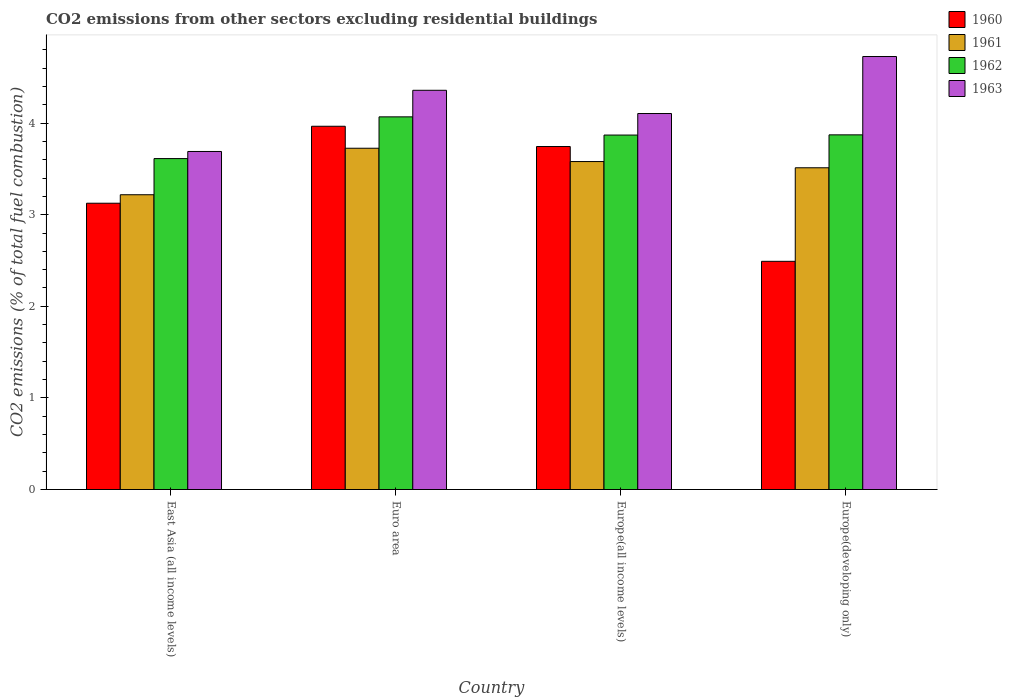How many different coloured bars are there?
Your answer should be compact. 4. How many groups of bars are there?
Offer a terse response. 4. How many bars are there on the 2nd tick from the left?
Provide a succinct answer. 4. What is the label of the 4th group of bars from the left?
Your answer should be very brief. Europe(developing only). What is the total CO2 emitted in 1963 in Europe(all income levels)?
Your answer should be very brief. 4.1. Across all countries, what is the maximum total CO2 emitted in 1962?
Offer a terse response. 4.07. Across all countries, what is the minimum total CO2 emitted in 1962?
Provide a short and direct response. 3.61. In which country was the total CO2 emitted in 1960 minimum?
Provide a short and direct response. Europe(developing only). What is the total total CO2 emitted in 1960 in the graph?
Offer a very short reply. 13.33. What is the difference between the total CO2 emitted in 1961 in East Asia (all income levels) and that in Europe(all income levels)?
Provide a short and direct response. -0.36. What is the difference between the total CO2 emitted in 1962 in Euro area and the total CO2 emitted in 1961 in East Asia (all income levels)?
Your answer should be very brief. 0.85. What is the average total CO2 emitted in 1961 per country?
Provide a succinct answer. 3.51. What is the difference between the total CO2 emitted of/in 1960 and total CO2 emitted of/in 1961 in Europe(all income levels)?
Make the answer very short. 0.16. What is the ratio of the total CO2 emitted in 1962 in East Asia (all income levels) to that in Europe(developing only)?
Offer a terse response. 0.93. What is the difference between the highest and the second highest total CO2 emitted in 1961?
Make the answer very short. 0.07. What is the difference between the highest and the lowest total CO2 emitted in 1960?
Keep it short and to the point. 1.47. In how many countries, is the total CO2 emitted in 1960 greater than the average total CO2 emitted in 1960 taken over all countries?
Your answer should be very brief. 2. What does the 1st bar from the left in Euro area represents?
Make the answer very short. 1960. Is it the case that in every country, the sum of the total CO2 emitted in 1960 and total CO2 emitted in 1963 is greater than the total CO2 emitted in 1962?
Provide a succinct answer. Yes. How many bars are there?
Make the answer very short. 16. Are all the bars in the graph horizontal?
Offer a very short reply. No. What is the difference between two consecutive major ticks on the Y-axis?
Ensure brevity in your answer.  1. Does the graph contain any zero values?
Ensure brevity in your answer.  No. How many legend labels are there?
Make the answer very short. 4. How are the legend labels stacked?
Your answer should be very brief. Vertical. What is the title of the graph?
Offer a very short reply. CO2 emissions from other sectors excluding residential buildings. Does "1979" appear as one of the legend labels in the graph?
Ensure brevity in your answer.  No. What is the label or title of the X-axis?
Your answer should be compact. Country. What is the label or title of the Y-axis?
Your answer should be very brief. CO2 emissions (% of total fuel combustion). What is the CO2 emissions (% of total fuel combustion) in 1960 in East Asia (all income levels)?
Provide a short and direct response. 3.13. What is the CO2 emissions (% of total fuel combustion) in 1961 in East Asia (all income levels)?
Your response must be concise. 3.22. What is the CO2 emissions (% of total fuel combustion) of 1962 in East Asia (all income levels)?
Your answer should be compact. 3.61. What is the CO2 emissions (% of total fuel combustion) of 1963 in East Asia (all income levels)?
Ensure brevity in your answer.  3.69. What is the CO2 emissions (% of total fuel combustion) in 1960 in Euro area?
Ensure brevity in your answer.  3.97. What is the CO2 emissions (% of total fuel combustion) in 1961 in Euro area?
Provide a succinct answer. 3.73. What is the CO2 emissions (% of total fuel combustion) of 1962 in Euro area?
Your response must be concise. 4.07. What is the CO2 emissions (% of total fuel combustion) of 1963 in Euro area?
Your answer should be compact. 4.36. What is the CO2 emissions (% of total fuel combustion) of 1960 in Europe(all income levels)?
Your response must be concise. 3.74. What is the CO2 emissions (% of total fuel combustion) in 1961 in Europe(all income levels)?
Your answer should be very brief. 3.58. What is the CO2 emissions (% of total fuel combustion) in 1962 in Europe(all income levels)?
Your answer should be very brief. 3.87. What is the CO2 emissions (% of total fuel combustion) in 1963 in Europe(all income levels)?
Offer a terse response. 4.1. What is the CO2 emissions (% of total fuel combustion) in 1960 in Europe(developing only)?
Offer a terse response. 2.49. What is the CO2 emissions (% of total fuel combustion) of 1961 in Europe(developing only)?
Provide a succinct answer. 3.51. What is the CO2 emissions (% of total fuel combustion) of 1962 in Europe(developing only)?
Make the answer very short. 3.87. What is the CO2 emissions (% of total fuel combustion) in 1963 in Europe(developing only)?
Your answer should be compact. 4.73. Across all countries, what is the maximum CO2 emissions (% of total fuel combustion) in 1960?
Keep it short and to the point. 3.97. Across all countries, what is the maximum CO2 emissions (% of total fuel combustion) of 1961?
Ensure brevity in your answer.  3.73. Across all countries, what is the maximum CO2 emissions (% of total fuel combustion) in 1962?
Keep it short and to the point. 4.07. Across all countries, what is the maximum CO2 emissions (% of total fuel combustion) in 1963?
Your answer should be compact. 4.73. Across all countries, what is the minimum CO2 emissions (% of total fuel combustion) in 1960?
Make the answer very short. 2.49. Across all countries, what is the minimum CO2 emissions (% of total fuel combustion) in 1961?
Offer a very short reply. 3.22. Across all countries, what is the minimum CO2 emissions (% of total fuel combustion) in 1962?
Your response must be concise. 3.61. Across all countries, what is the minimum CO2 emissions (% of total fuel combustion) of 1963?
Provide a succinct answer. 3.69. What is the total CO2 emissions (% of total fuel combustion) of 1960 in the graph?
Your answer should be very brief. 13.32. What is the total CO2 emissions (% of total fuel combustion) in 1961 in the graph?
Offer a very short reply. 14.03. What is the total CO2 emissions (% of total fuel combustion) in 1962 in the graph?
Offer a very short reply. 15.42. What is the total CO2 emissions (% of total fuel combustion) in 1963 in the graph?
Offer a very short reply. 16.88. What is the difference between the CO2 emissions (% of total fuel combustion) in 1960 in East Asia (all income levels) and that in Euro area?
Give a very brief answer. -0.84. What is the difference between the CO2 emissions (% of total fuel combustion) of 1961 in East Asia (all income levels) and that in Euro area?
Keep it short and to the point. -0.51. What is the difference between the CO2 emissions (% of total fuel combustion) in 1962 in East Asia (all income levels) and that in Euro area?
Ensure brevity in your answer.  -0.46. What is the difference between the CO2 emissions (% of total fuel combustion) in 1963 in East Asia (all income levels) and that in Euro area?
Ensure brevity in your answer.  -0.67. What is the difference between the CO2 emissions (% of total fuel combustion) of 1960 in East Asia (all income levels) and that in Europe(all income levels)?
Your answer should be very brief. -0.62. What is the difference between the CO2 emissions (% of total fuel combustion) in 1961 in East Asia (all income levels) and that in Europe(all income levels)?
Make the answer very short. -0.36. What is the difference between the CO2 emissions (% of total fuel combustion) in 1962 in East Asia (all income levels) and that in Europe(all income levels)?
Give a very brief answer. -0.26. What is the difference between the CO2 emissions (% of total fuel combustion) of 1963 in East Asia (all income levels) and that in Europe(all income levels)?
Provide a succinct answer. -0.41. What is the difference between the CO2 emissions (% of total fuel combustion) of 1960 in East Asia (all income levels) and that in Europe(developing only)?
Make the answer very short. 0.63. What is the difference between the CO2 emissions (% of total fuel combustion) of 1961 in East Asia (all income levels) and that in Europe(developing only)?
Offer a very short reply. -0.29. What is the difference between the CO2 emissions (% of total fuel combustion) in 1962 in East Asia (all income levels) and that in Europe(developing only)?
Your response must be concise. -0.26. What is the difference between the CO2 emissions (% of total fuel combustion) of 1963 in East Asia (all income levels) and that in Europe(developing only)?
Keep it short and to the point. -1.04. What is the difference between the CO2 emissions (% of total fuel combustion) in 1960 in Euro area and that in Europe(all income levels)?
Your answer should be compact. 0.22. What is the difference between the CO2 emissions (% of total fuel combustion) in 1961 in Euro area and that in Europe(all income levels)?
Your answer should be very brief. 0.15. What is the difference between the CO2 emissions (% of total fuel combustion) in 1962 in Euro area and that in Europe(all income levels)?
Offer a very short reply. 0.2. What is the difference between the CO2 emissions (% of total fuel combustion) in 1963 in Euro area and that in Europe(all income levels)?
Provide a short and direct response. 0.25. What is the difference between the CO2 emissions (% of total fuel combustion) of 1960 in Euro area and that in Europe(developing only)?
Your answer should be compact. 1.47. What is the difference between the CO2 emissions (% of total fuel combustion) in 1961 in Euro area and that in Europe(developing only)?
Your response must be concise. 0.21. What is the difference between the CO2 emissions (% of total fuel combustion) in 1962 in Euro area and that in Europe(developing only)?
Your answer should be compact. 0.2. What is the difference between the CO2 emissions (% of total fuel combustion) in 1963 in Euro area and that in Europe(developing only)?
Give a very brief answer. -0.37. What is the difference between the CO2 emissions (% of total fuel combustion) of 1960 in Europe(all income levels) and that in Europe(developing only)?
Make the answer very short. 1.25. What is the difference between the CO2 emissions (% of total fuel combustion) in 1961 in Europe(all income levels) and that in Europe(developing only)?
Offer a very short reply. 0.07. What is the difference between the CO2 emissions (% of total fuel combustion) of 1962 in Europe(all income levels) and that in Europe(developing only)?
Give a very brief answer. -0. What is the difference between the CO2 emissions (% of total fuel combustion) in 1963 in Europe(all income levels) and that in Europe(developing only)?
Ensure brevity in your answer.  -0.62. What is the difference between the CO2 emissions (% of total fuel combustion) of 1960 in East Asia (all income levels) and the CO2 emissions (% of total fuel combustion) of 1961 in Euro area?
Offer a terse response. -0.6. What is the difference between the CO2 emissions (% of total fuel combustion) of 1960 in East Asia (all income levels) and the CO2 emissions (% of total fuel combustion) of 1962 in Euro area?
Give a very brief answer. -0.94. What is the difference between the CO2 emissions (% of total fuel combustion) in 1960 in East Asia (all income levels) and the CO2 emissions (% of total fuel combustion) in 1963 in Euro area?
Provide a succinct answer. -1.23. What is the difference between the CO2 emissions (% of total fuel combustion) of 1961 in East Asia (all income levels) and the CO2 emissions (% of total fuel combustion) of 1962 in Euro area?
Offer a terse response. -0.85. What is the difference between the CO2 emissions (% of total fuel combustion) of 1961 in East Asia (all income levels) and the CO2 emissions (% of total fuel combustion) of 1963 in Euro area?
Ensure brevity in your answer.  -1.14. What is the difference between the CO2 emissions (% of total fuel combustion) of 1962 in East Asia (all income levels) and the CO2 emissions (% of total fuel combustion) of 1963 in Euro area?
Give a very brief answer. -0.75. What is the difference between the CO2 emissions (% of total fuel combustion) of 1960 in East Asia (all income levels) and the CO2 emissions (% of total fuel combustion) of 1961 in Europe(all income levels)?
Provide a short and direct response. -0.45. What is the difference between the CO2 emissions (% of total fuel combustion) in 1960 in East Asia (all income levels) and the CO2 emissions (% of total fuel combustion) in 1962 in Europe(all income levels)?
Your response must be concise. -0.74. What is the difference between the CO2 emissions (% of total fuel combustion) in 1960 in East Asia (all income levels) and the CO2 emissions (% of total fuel combustion) in 1963 in Europe(all income levels)?
Your answer should be very brief. -0.98. What is the difference between the CO2 emissions (% of total fuel combustion) of 1961 in East Asia (all income levels) and the CO2 emissions (% of total fuel combustion) of 1962 in Europe(all income levels)?
Make the answer very short. -0.65. What is the difference between the CO2 emissions (% of total fuel combustion) in 1961 in East Asia (all income levels) and the CO2 emissions (% of total fuel combustion) in 1963 in Europe(all income levels)?
Provide a short and direct response. -0.89. What is the difference between the CO2 emissions (% of total fuel combustion) in 1962 in East Asia (all income levels) and the CO2 emissions (% of total fuel combustion) in 1963 in Europe(all income levels)?
Ensure brevity in your answer.  -0.49. What is the difference between the CO2 emissions (% of total fuel combustion) in 1960 in East Asia (all income levels) and the CO2 emissions (% of total fuel combustion) in 1961 in Europe(developing only)?
Keep it short and to the point. -0.39. What is the difference between the CO2 emissions (% of total fuel combustion) in 1960 in East Asia (all income levels) and the CO2 emissions (% of total fuel combustion) in 1962 in Europe(developing only)?
Give a very brief answer. -0.75. What is the difference between the CO2 emissions (% of total fuel combustion) of 1960 in East Asia (all income levels) and the CO2 emissions (% of total fuel combustion) of 1963 in Europe(developing only)?
Offer a very short reply. -1.6. What is the difference between the CO2 emissions (% of total fuel combustion) of 1961 in East Asia (all income levels) and the CO2 emissions (% of total fuel combustion) of 1962 in Europe(developing only)?
Offer a very short reply. -0.65. What is the difference between the CO2 emissions (% of total fuel combustion) of 1961 in East Asia (all income levels) and the CO2 emissions (% of total fuel combustion) of 1963 in Europe(developing only)?
Offer a very short reply. -1.51. What is the difference between the CO2 emissions (% of total fuel combustion) of 1962 in East Asia (all income levels) and the CO2 emissions (% of total fuel combustion) of 1963 in Europe(developing only)?
Provide a succinct answer. -1.11. What is the difference between the CO2 emissions (% of total fuel combustion) of 1960 in Euro area and the CO2 emissions (% of total fuel combustion) of 1961 in Europe(all income levels)?
Offer a terse response. 0.39. What is the difference between the CO2 emissions (% of total fuel combustion) of 1960 in Euro area and the CO2 emissions (% of total fuel combustion) of 1962 in Europe(all income levels)?
Keep it short and to the point. 0.1. What is the difference between the CO2 emissions (% of total fuel combustion) of 1960 in Euro area and the CO2 emissions (% of total fuel combustion) of 1963 in Europe(all income levels)?
Ensure brevity in your answer.  -0.14. What is the difference between the CO2 emissions (% of total fuel combustion) in 1961 in Euro area and the CO2 emissions (% of total fuel combustion) in 1962 in Europe(all income levels)?
Make the answer very short. -0.14. What is the difference between the CO2 emissions (% of total fuel combustion) in 1961 in Euro area and the CO2 emissions (% of total fuel combustion) in 1963 in Europe(all income levels)?
Give a very brief answer. -0.38. What is the difference between the CO2 emissions (% of total fuel combustion) in 1962 in Euro area and the CO2 emissions (% of total fuel combustion) in 1963 in Europe(all income levels)?
Ensure brevity in your answer.  -0.04. What is the difference between the CO2 emissions (% of total fuel combustion) of 1960 in Euro area and the CO2 emissions (% of total fuel combustion) of 1961 in Europe(developing only)?
Keep it short and to the point. 0.45. What is the difference between the CO2 emissions (% of total fuel combustion) in 1960 in Euro area and the CO2 emissions (% of total fuel combustion) in 1962 in Europe(developing only)?
Keep it short and to the point. 0.09. What is the difference between the CO2 emissions (% of total fuel combustion) in 1960 in Euro area and the CO2 emissions (% of total fuel combustion) in 1963 in Europe(developing only)?
Give a very brief answer. -0.76. What is the difference between the CO2 emissions (% of total fuel combustion) of 1961 in Euro area and the CO2 emissions (% of total fuel combustion) of 1962 in Europe(developing only)?
Your response must be concise. -0.15. What is the difference between the CO2 emissions (% of total fuel combustion) of 1961 in Euro area and the CO2 emissions (% of total fuel combustion) of 1963 in Europe(developing only)?
Give a very brief answer. -1. What is the difference between the CO2 emissions (% of total fuel combustion) in 1962 in Euro area and the CO2 emissions (% of total fuel combustion) in 1963 in Europe(developing only)?
Offer a very short reply. -0.66. What is the difference between the CO2 emissions (% of total fuel combustion) of 1960 in Europe(all income levels) and the CO2 emissions (% of total fuel combustion) of 1961 in Europe(developing only)?
Offer a terse response. 0.23. What is the difference between the CO2 emissions (% of total fuel combustion) in 1960 in Europe(all income levels) and the CO2 emissions (% of total fuel combustion) in 1962 in Europe(developing only)?
Your answer should be very brief. -0.13. What is the difference between the CO2 emissions (% of total fuel combustion) in 1960 in Europe(all income levels) and the CO2 emissions (% of total fuel combustion) in 1963 in Europe(developing only)?
Make the answer very short. -0.98. What is the difference between the CO2 emissions (% of total fuel combustion) of 1961 in Europe(all income levels) and the CO2 emissions (% of total fuel combustion) of 1962 in Europe(developing only)?
Keep it short and to the point. -0.29. What is the difference between the CO2 emissions (% of total fuel combustion) in 1961 in Europe(all income levels) and the CO2 emissions (% of total fuel combustion) in 1963 in Europe(developing only)?
Provide a short and direct response. -1.15. What is the difference between the CO2 emissions (% of total fuel combustion) in 1962 in Europe(all income levels) and the CO2 emissions (% of total fuel combustion) in 1963 in Europe(developing only)?
Your answer should be compact. -0.86. What is the average CO2 emissions (% of total fuel combustion) in 1960 per country?
Make the answer very short. 3.33. What is the average CO2 emissions (% of total fuel combustion) in 1961 per country?
Your answer should be compact. 3.51. What is the average CO2 emissions (% of total fuel combustion) of 1962 per country?
Keep it short and to the point. 3.86. What is the average CO2 emissions (% of total fuel combustion) in 1963 per country?
Provide a succinct answer. 4.22. What is the difference between the CO2 emissions (% of total fuel combustion) of 1960 and CO2 emissions (% of total fuel combustion) of 1961 in East Asia (all income levels)?
Make the answer very short. -0.09. What is the difference between the CO2 emissions (% of total fuel combustion) of 1960 and CO2 emissions (% of total fuel combustion) of 1962 in East Asia (all income levels)?
Offer a very short reply. -0.49. What is the difference between the CO2 emissions (% of total fuel combustion) of 1960 and CO2 emissions (% of total fuel combustion) of 1963 in East Asia (all income levels)?
Give a very brief answer. -0.56. What is the difference between the CO2 emissions (% of total fuel combustion) in 1961 and CO2 emissions (% of total fuel combustion) in 1962 in East Asia (all income levels)?
Make the answer very short. -0.39. What is the difference between the CO2 emissions (% of total fuel combustion) of 1961 and CO2 emissions (% of total fuel combustion) of 1963 in East Asia (all income levels)?
Offer a terse response. -0.47. What is the difference between the CO2 emissions (% of total fuel combustion) of 1962 and CO2 emissions (% of total fuel combustion) of 1963 in East Asia (all income levels)?
Offer a terse response. -0.08. What is the difference between the CO2 emissions (% of total fuel combustion) in 1960 and CO2 emissions (% of total fuel combustion) in 1961 in Euro area?
Offer a terse response. 0.24. What is the difference between the CO2 emissions (% of total fuel combustion) in 1960 and CO2 emissions (% of total fuel combustion) in 1962 in Euro area?
Make the answer very short. -0.1. What is the difference between the CO2 emissions (% of total fuel combustion) of 1960 and CO2 emissions (% of total fuel combustion) of 1963 in Euro area?
Keep it short and to the point. -0.39. What is the difference between the CO2 emissions (% of total fuel combustion) of 1961 and CO2 emissions (% of total fuel combustion) of 1962 in Euro area?
Make the answer very short. -0.34. What is the difference between the CO2 emissions (% of total fuel combustion) in 1961 and CO2 emissions (% of total fuel combustion) in 1963 in Euro area?
Your response must be concise. -0.63. What is the difference between the CO2 emissions (% of total fuel combustion) of 1962 and CO2 emissions (% of total fuel combustion) of 1963 in Euro area?
Offer a very short reply. -0.29. What is the difference between the CO2 emissions (% of total fuel combustion) in 1960 and CO2 emissions (% of total fuel combustion) in 1961 in Europe(all income levels)?
Provide a short and direct response. 0.16. What is the difference between the CO2 emissions (% of total fuel combustion) in 1960 and CO2 emissions (% of total fuel combustion) in 1962 in Europe(all income levels)?
Offer a very short reply. -0.13. What is the difference between the CO2 emissions (% of total fuel combustion) in 1960 and CO2 emissions (% of total fuel combustion) in 1963 in Europe(all income levels)?
Provide a short and direct response. -0.36. What is the difference between the CO2 emissions (% of total fuel combustion) in 1961 and CO2 emissions (% of total fuel combustion) in 1962 in Europe(all income levels)?
Keep it short and to the point. -0.29. What is the difference between the CO2 emissions (% of total fuel combustion) in 1961 and CO2 emissions (% of total fuel combustion) in 1963 in Europe(all income levels)?
Give a very brief answer. -0.52. What is the difference between the CO2 emissions (% of total fuel combustion) in 1962 and CO2 emissions (% of total fuel combustion) in 1963 in Europe(all income levels)?
Make the answer very short. -0.23. What is the difference between the CO2 emissions (% of total fuel combustion) in 1960 and CO2 emissions (% of total fuel combustion) in 1961 in Europe(developing only)?
Keep it short and to the point. -1.02. What is the difference between the CO2 emissions (% of total fuel combustion) of 1960 and CO2 emissions (% of total fuel combustion) of 1962 in Europe(developing only)?
Make the answer very short. -1.38. What is the difference between the CO2 emissions (% of total fuel combustion) of 1960 and CO2 emissions (% of total fuel combustion) of 1963 in Europe(developing only)?
Offer a terse response. -2.24. What is the difference between the CO2 emissions (% of total fuel combustion) of 1961 and CO2 emissions (% of total fuel combustion) of 1962 in Europe(developing only)?
Give a very brief answer. -0.36. What is the difference between the CO2 emissions (% of total fuel combustion) in 1961 and CO2 emissions (% of total fuel combustion) in 1963 in Europe(developing only)?
Give a very brief answer. -1.21. What is the difference between the CO2 emissions (% of total fuel combustion) in 1962 and CO2 emissions (% of total fuel combustion) in 1963 in Europe(developing only)?
Provide a short and direct response. -0.85. What is the ratio of the CO2 emissions (% of total fuel combustion) in 1960 in East Asia (all income levels) to that in Euro area?
Provide a succinct answer. 0.79. What is the ratio of the CO2 emissions (% of total fuel combustion) in 1961 in East Asia (all income levels) to that in Euro area?
Provide a succinct answer. 0.86. What is the ratio of the CO2 emissions (% of total fuel combustion) in 1962 in East Asia (all income levels) to that in Euro area?
Offer a terse response. 0.89. What is the ratio of the CO2 emissions (% of total fuel combustion) in 1963 in East Asia (all income levels) to that in Euro area?
Provide a short and direct response. 0.85. What is the ratio of the CO2 emissions (% of total fuel combustion) in 1960 in East Asia (all income levels) to that in Europe(all income levels)?
Offer a terse response. 0.83. What is the ratio of the CO2 emissions (% of total fuel combustion) of 1961 in East Asia (all income levels) to that in Europe(all income levels)?
Your response must be concise. 0.9. What is the ratio of the CO2 emissions (% of total fuel combustion) of 1962 in East Asia (all income levels) to that in Europe(all income levels)?
Provide a succinct answer. 0.93. What is the ratio of the CO2 emissions (% of total fuel combustion) of 1963 in East Asia (all income levels) to that in Europe(all income levels)?
Give a very brief answer. 0.9. What is the ratio of the CO2 emissions (% of total fuel combustion) of 1960 in East Asia (all income levels) to that in Europe(developing only)?
Your response must be concise. 1.25. What is the ratio of the CO2 emissions (% of total fuel combustion) of 1961 in East Asia (all income levels) to that in Europe(developing only)?
Your answer should be compact. 0.92. What is the ratio of the CO2 emissions (% of total fuel combustion) of 1962 in East Asia (all income levels) to that in Europe(developing only)?
Make the answer very short. 0.93. What is the ratio of the CO2 emissions (% of total fuel combustion) in 1963 in East Asia (all income levels) to that in Europe(developing only)?
Give a very brief answer. 0.78. What is the ratio of the CO2 emissions (% of total fuel combustion) of 1960 in Euro area to that in Europe(all income levels)?
Offer a very short reply. 1.06. What is the ratio of the CO2 emissions (% of total fuel combustion) in 1961 in Euro area to that in Europe(all income levels)?
Your answer should be very brief. 1.04. What is the ratio of the CO2 emissions (% of total fuel combustion) of 1962 in Euro area to that in Europe(all income levels)?
Make the answer very short. 1.05. What is the ratio of the CO2 emissions (% of total fuel combustion) in 1963 in Euro area to that in Europe(all income levels)?
Your answer should be compact. 1.06. What is the ratio of the CO2 emissions (% of total fuel combustion) of 1960 in Euro area to that in Europe(developing only)?
Offer a very short reply. 1.59. What is the ratio of the CO2 emissions (% of total fuel combustion) of 1961 in Euro area to that in Europe(developing only)?
Your answer should be compact. 1.06. What is the ratio of the CO2 emissions (% of total fuel combustion) of 1962 in Euro area to that in Europe(developing only)?
Ensure brevity in your answer.  1.05. What is the ratio of the CO2 emissions (% of total fuel combustion) in 1963 in Euro area to that in Europe(developing only)?
Provide a succinct answer. 0.92. What is the ratio of the CO2 emissions (% of total fuel combustion) in 1960 in Europe(all income levels) to that in Europe(developing only)?
Ensure brevity in your answer.  1.5. What is the ratio of the CO2 emissions (% of total fuel combustion) of 1961 in Europe(all income levels) to that in Europe(developing only)?
Your answer should be very brief. 1.02. What is the ratio of the CO2 emissions (% of total fuel combustion) of 1963 in Europe(all income levels) to that in Europe(developing only)?
Provide a short and direct response. 0.87. What is the difference between the highest and the second highest CO2 emissions (% of total fuel combustion) in 1960?
Offer a terse response. 0.22. What is the difference between the highest and the second highest CO2 emissions (% of total fuel combustion) in 1961?
Offer a very short reply. 0.15. What is the difference between the highest and the second highest CO2 emissions (% of total fuel combustion) in 1962?
Ensure brevity in your answer.  0.2. What is the difference between the highest and the second highest CO2 emissions (% of total fuel combustion) in 1963?
Ensure brevity in your answer.  0.37. What is the difference between the highest and the lowest CO2 emissions (% of total fuel combustion) of 1960?
Provide a short and direct response. 1.47. What is the difference between the highest and the lowest CO2 emissions (% of total fuel combustion) in 1961?
Make the answer very short. 0.51. What is the difference between the highest and the lowest CO2 emissions (% of total fuel combustion) of 1962?
Provide a short and direct response. 0.46. What is the difference between the highest and the lowest CO2 emissions (% of total fuel combustion) of 1963?
Offer a terse response. 1.04. 